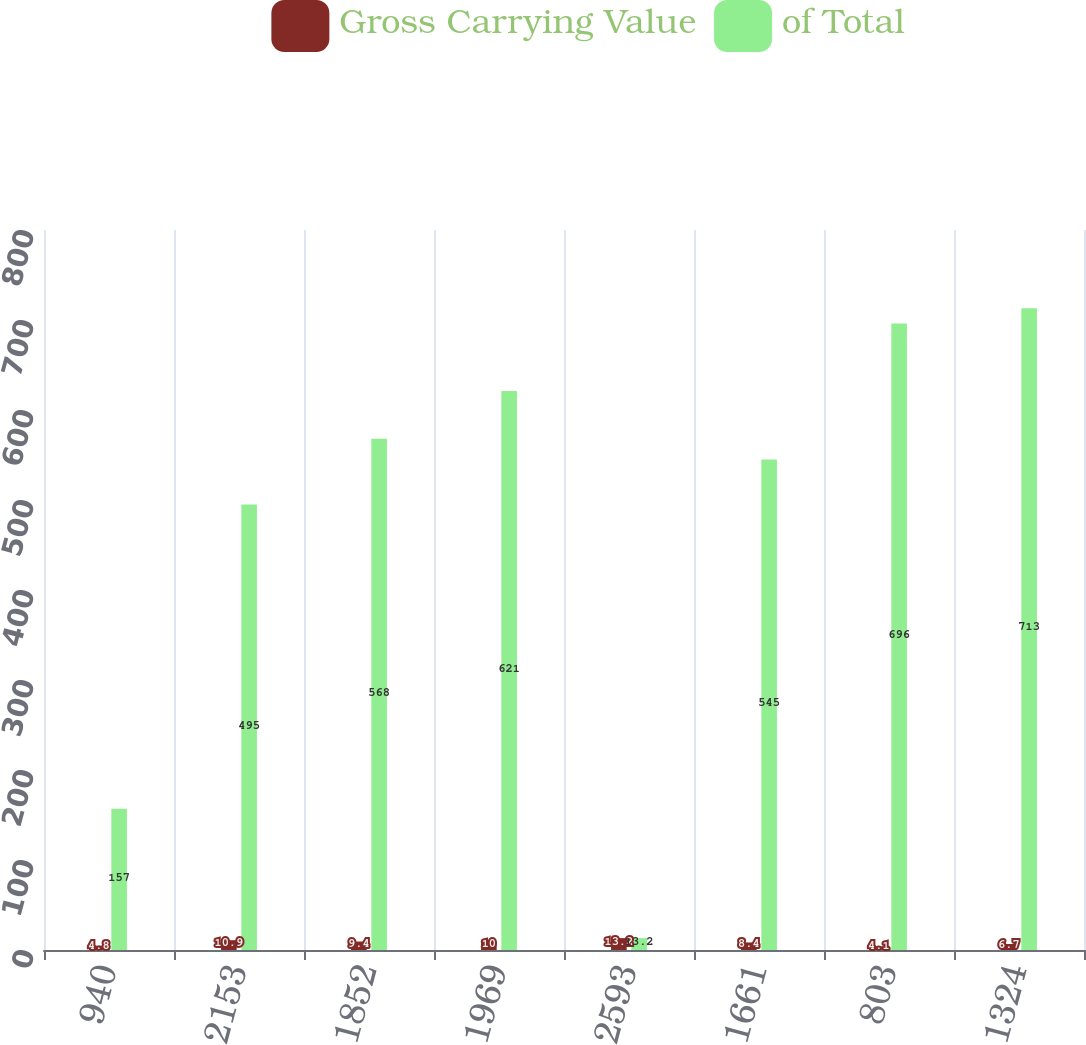Convert chart. <chart><loc_0><loc_0><loc_500><loc_500><stacked_bar_chart><ecel><fcel>940<fcel>2153<fcel>1852<fcel>1969<fcel>2593<fcel>1661<fcel>803<fcel>1324<nl><fcel>Gross Carrying Value<fcel>4.8<fcel>10.9<fcel>9.4<fcel>10<fcel>13.2<fcel>8.4<fcel>4.1<fcel>6.7<nl><fcel>of Total<fcel>157<fcel>495<fcel>568<fcel>621<fcel>13.2<fcel>545<fcel>696<fcel>713<nl></chart> 